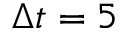<formula> <loc_0><loc_0><loc_500><loc_500>\Delta t = 5</formula> 